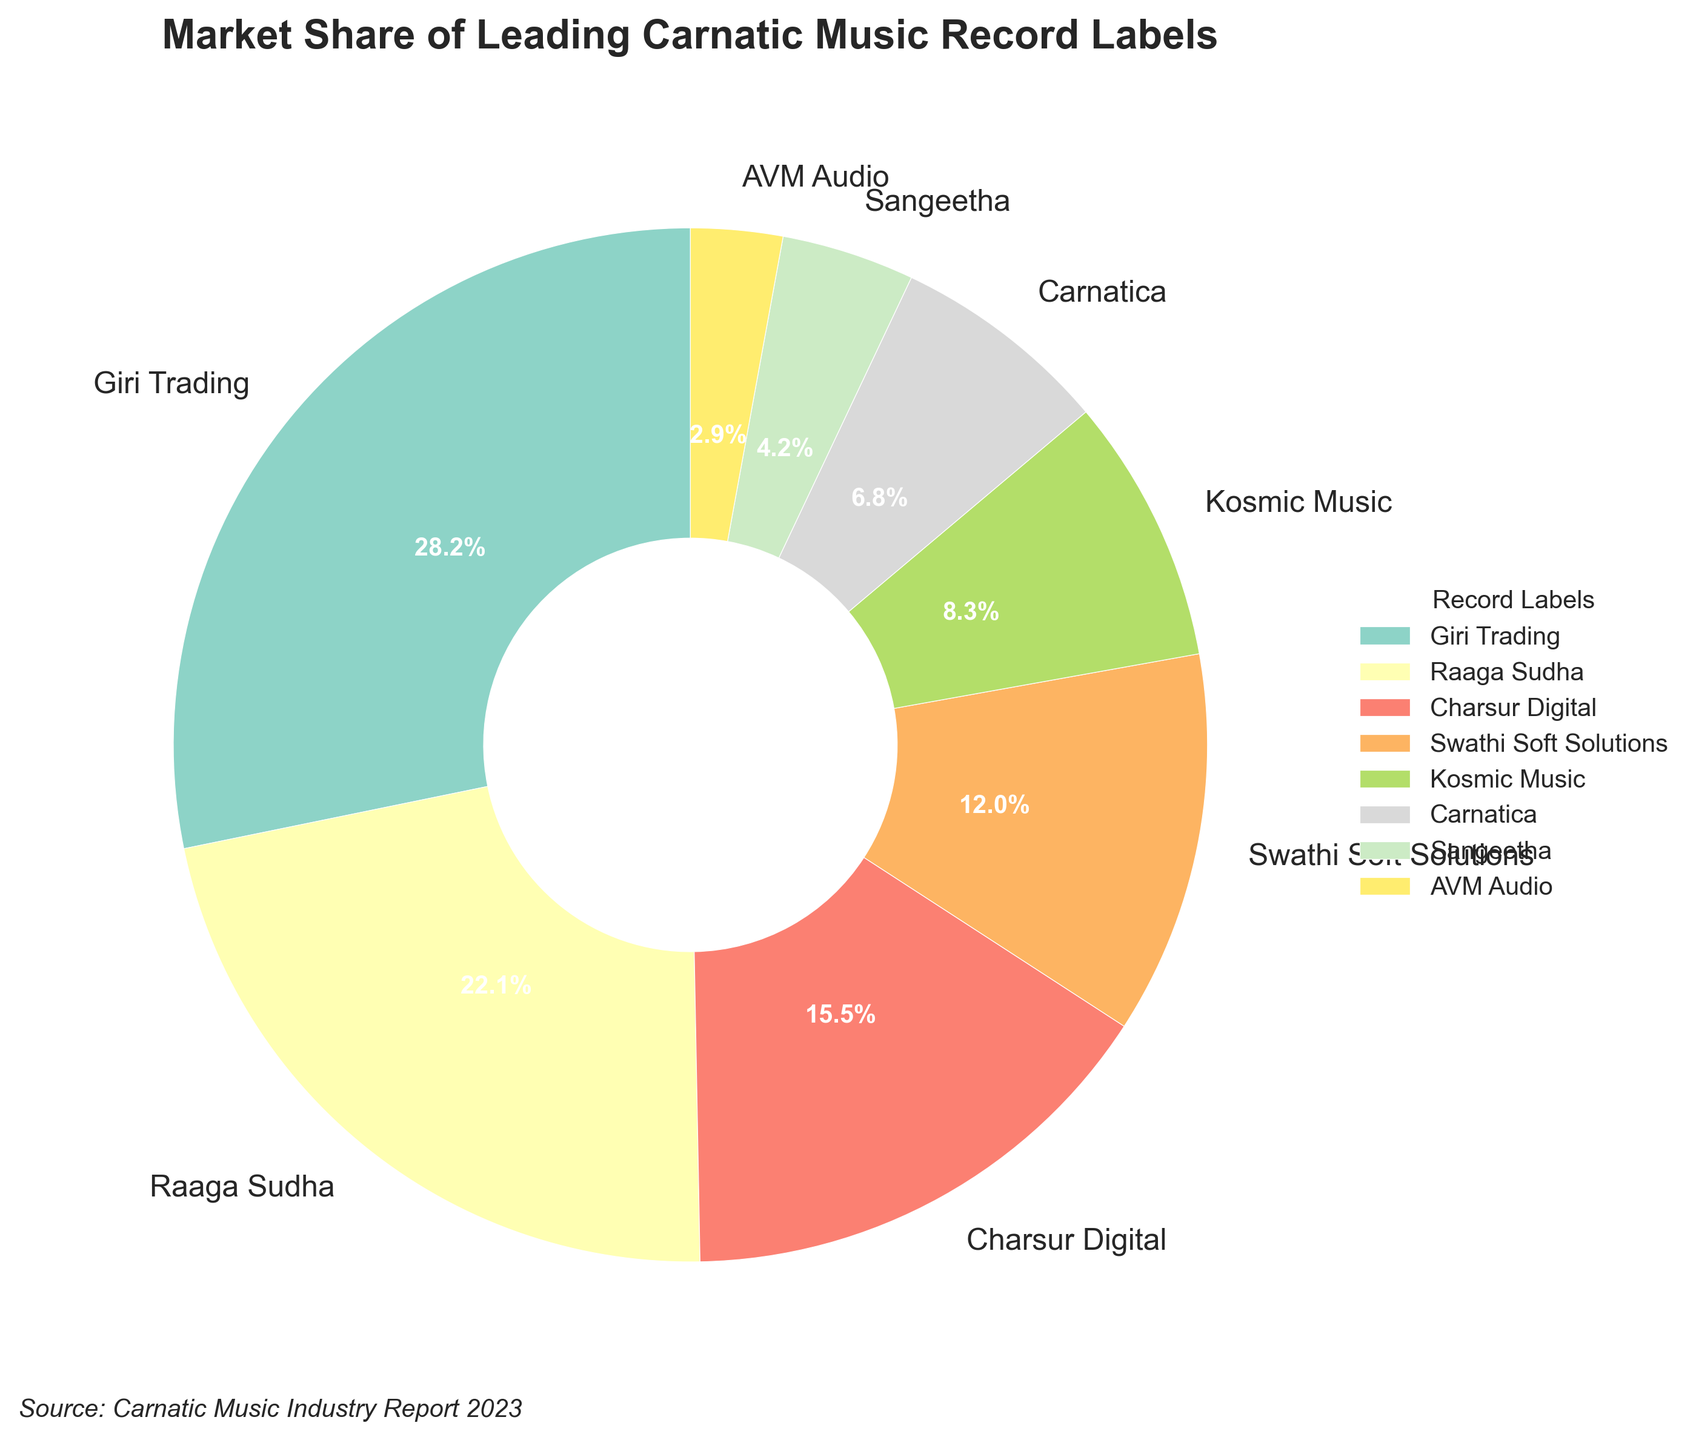Which record label has the highest market share? The record labels and their market shares are clearly labeled in the pie chart. The segment labeled "Giri Trading" covers the largest area of the pie, indicating it has the highest market share.
Answer: Giri Trading How much more market share does Giri Trading have compared to Raaga Sudha? Giri Trading has a market share of 28.5%, and Raaga Sudha has 22.3%. Subtracting Raaga Sudha’s market share from Giri Trading’s market share: 28.5% - 22.3% = 6.2%.
Answer: 6.2% Which label has the smallest market share? The smallest segment in the pie chart corresponds to "AVM Audio", which indicates it has the smallest market share.
Answer: AVM Audio What is the combined market share of Charsur Digital and Swathi Soft Solutions? The market share of Charsur Digital is 15.7%, and Swathi Soft Solutions is 12.1%. Adding these together: 15.7% + 12.1% = 27.8%.
Answer: 27.8% Are there any labels with a market share less than 5%? The labels with the corresponding market shares on the pie chart show that both Sangeetha and AVM Audio have market shares below 5%.
Answer: Yes Which two labels combined have a market share just over 50%? Combined market shares: Giri Trading (28.5%) and Raaga Sudha (22.3%) together make 28.5% + 22.3% = 50.8%.
Answer: Giri Trading and Raaga Sudha What is the market share difference between the label with the third largest and the label with the second smallest market share? Charsur Digital (third largest) has 15.7%, and Carnatica (second smallest) has 6.9%. The difference is 15.7% - 6.9% = 8.8%.
Answer: 8.8% How many labels have a market share that is at least 10% but less than 20%? The labels within the specified market share range are Charsur Digital (15.7%) and Swathi Soft Solutions (12.1%). So, there are 2 labels.
Answer: 2 Which segment in the pie chart is represented by a greenish color? In the pie chart, Kosmic Music is associated with a greenish color.
Answer: Kosmic Music 